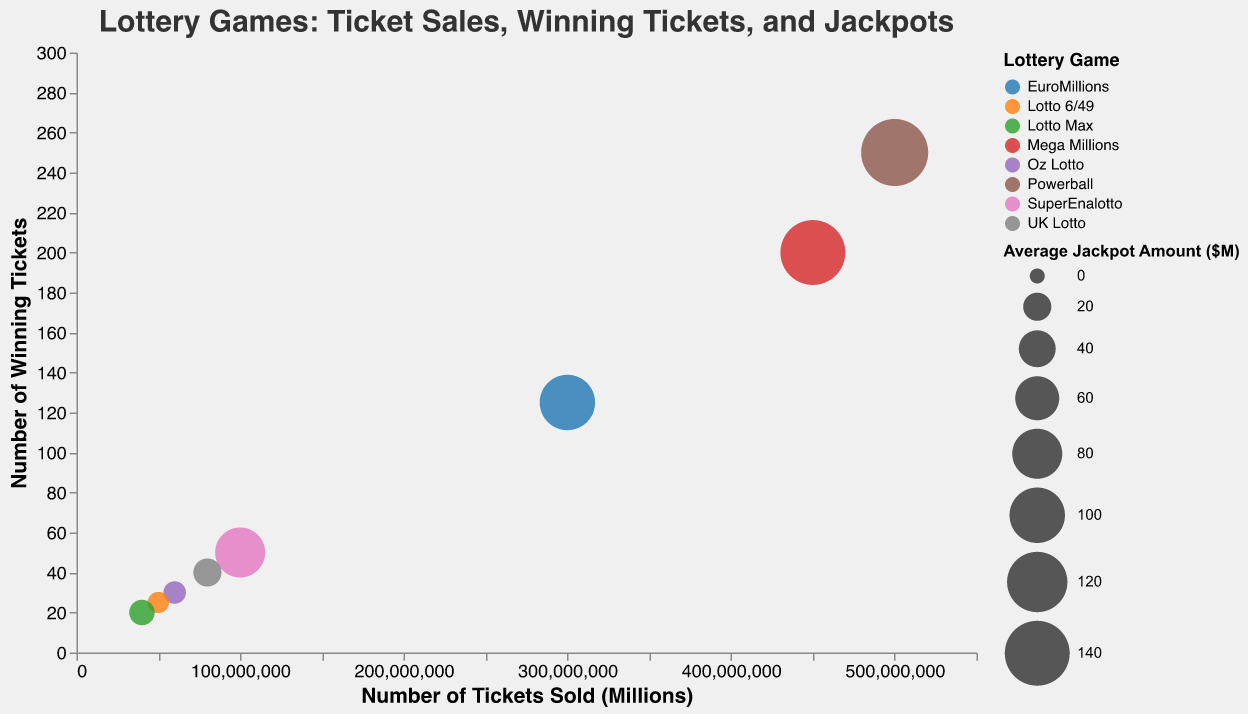What's the title of the figure? The title of the figure is typically found at the top and describes the main topic of the chart. In this case, it indicates information about ticket sales, winning tickets, and jackpots of different lottery games.
Answer: Lottery Games: Ticket Sales, Winning Tickets, and Jackpots How many data points are plotted in the figure? Each bubble represents a point in the chart corresponding to a lottery game. Counting these gives the total number of data points. Here, there are bubbles for: Powerball, Mega Millions, EuroMillions, SuperEnalotto, UK Lotto, Oz Lotto, Lotto 6/49, and Lotto Max.
Answer: 8 Which lottery game has the highest number of tickets sold? By looking along the x-axis, which indicates the number of tickets sold and finding the rightmost bubble, we can identify the lottery game with the highest sales.
Answer: Powerball Which lottery game has the fewest winning tickets? By looking along the y-axis, which indicates the number of winning tickets and finding the lowest positioned bubble, we can identify the lottery game with the fewest winning tickets.
Answer: Lotto Max What's the total number of winning tickets across all the lottery games plotted? Sum up the number of winning tickets for each lottery game: 250 (Powerball) + 200 (Mega Millions) + 125 (EuroMillions) + 50 (SuperEnalotto) + 40 (UK Lotto) + 30 (Oz Lotto) + 25 (Lotto 6/49) + 20 (Lotto Max).
Answer: 740 Which lottery game has a higher average jackpot amount: UK Lotto or Oz Lotto? By comparing the sizes of the bubbles for UK Lotto and Oz Lotto since the size of the bubble is proportional to the average jackpot amount, we can see which is larger.
Answer: UK Lotto If you combine the number of tickets sold for Mega Millions and EuroMillions, how does it compare to Powerball? Add the number of tickets sold for Mega Millions (450,000,000) and EuroMillions (300,000,000), then compare the sum to Powerball's ticket sales (500,000,000). 450,000,000 + 300,000,000 is equal to 750,000,000 which is greater than 500,000,000.
Answer: Greater than What can you say about the relationship between the number of tickets sold and the number of winning tickets? General observation of the x-axis (tickets sold) and y-axis (winning tickets) shows that as the number of tickets sold increases, the number of winning tickets also tends to increase. There seems to be a positive correlation.
Answer: Positive correlation Which lottery game has the smallest bubble, and what does that imply about its average jackpot amount? The smallest bubble indicates the game with the smallest average jackpot amount. By identifying the smallest bubble, we identify the game and infer its average jackpot.
Answer: Oz Lotto, implies it has the smallest average jackpot amount of $10 million 